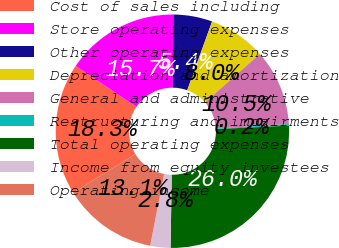Convert chart. <chart><loc_0><loc_0><loc_500><loc_500><pie_chart><fcel>Cost of sales including<fcel>Store operating expenses<fcel>Other operating expenses<fcel>Depreciation and amortization<fcel>General and administrative<fcel>Restructuring and impairments<fcel>Total operating expenses<fcel>Income from equity investees<fcel>Operating income<nl><fcel>18.28%<fcel>15.7%<fcel>5.38%<fcel>7.96%<fcel>10.54%<fcel>0.22%<fcel>26.02%<fcel>2.8%<fcel>13.12%<nl></chart> 